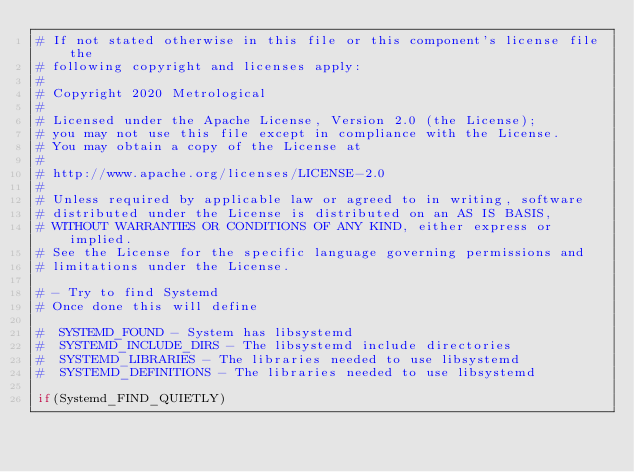Convert code to text. <code><loc_0><loc_0><loc_500><loc_500><_CMake_># If not stated otherwise in this file or this component's license file the
# following copyright and licenses apply:
#
# Copyright 2020 Metrological
#
# Licensed under the Apache License, Version 2.0 (the License);
# you may not use this file except in compliance with the License.
# You may obtain a copy of the License at
#
# http://www.apache.org/licenses/LICENSE-2.0
#
# Unless required by applicable law or agreed to in writing, software
# distributed under the License is distributed on an AS IS BASIS,
# WITHOUT WARRANTIES OR CONDITIONS OF ANY KIND, either express or implied.
# See the License for the specific language governing permissions and
# limitations under the License.

# - Try to find Systemd
# Once done this will define

#  SYSTEMD_FOUND - System has libsystemd
#  SYSTEMD_INCLUDE_DIRS - The libsystemd include directories
#  SYSTEMD_LIBRARIES - The libraries needed to use libsystemd
#  SYSTEMD_DEFINITIONS - The libraries needed to use libsystemd

if(Systemd_FIND_QUIETLY)</code> 